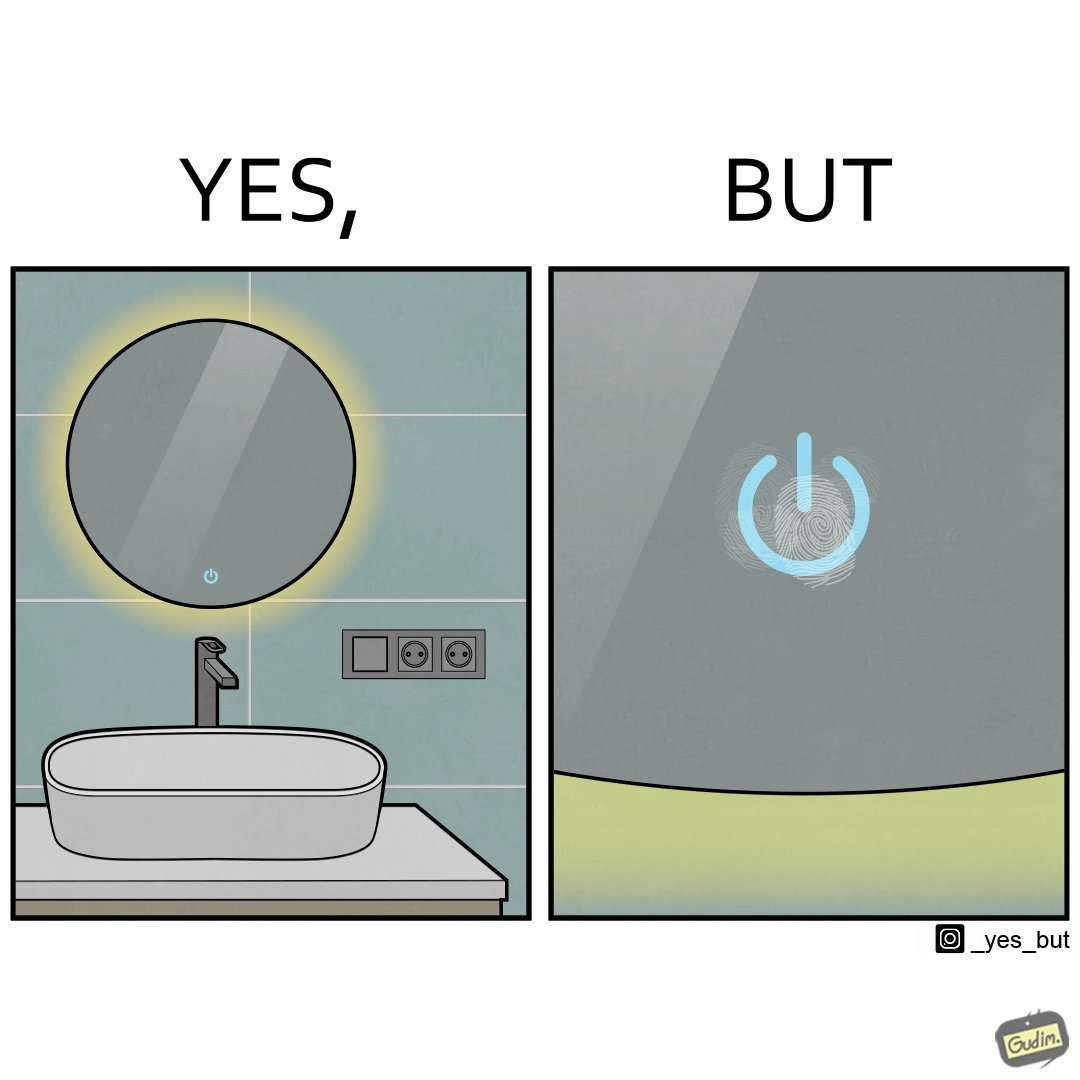Why is this image considered satirical? The image is funny, as the bathroom sink looks clean, but when you zoom into the touch power button, you can see fingerprint smudges. 